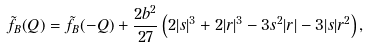<formula> <loc_0><loc_0><loc_500><loc_500>\tilde { f } _ { B } ( Q ) = \tilde { f } _ { B } ( - Q ) + \frac { 2 b ^ { 2 } } { 2 7 } \left ( 2 | s | ^ { 3 } + 2 | r | ^ { 3 } - 3 s ^ { 2 } | r | - 3 | s | r ^ { 2 } \right ) ,</formula> 